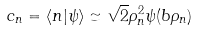<formula> <loc_0><loc_0><loc_500><loc_500>c _ { n } = \left \langle n | \psi \right \rangle \simeq \sqrt { 2 } \rho _ { n } ^ { 2 } \psi ( b \rho _ { n } )</formula> 